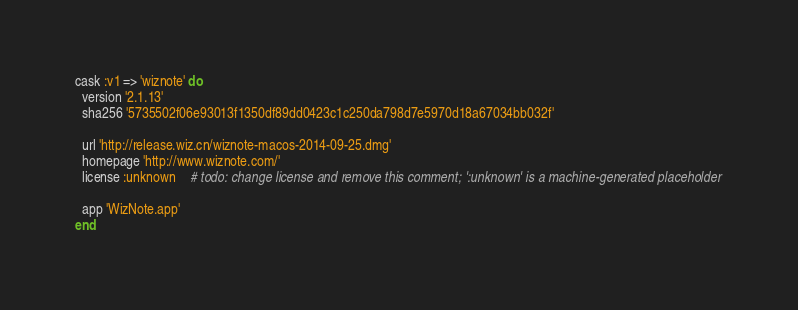Convert code to text. <code><loc_0><loc_0><loc_500><loc_500><_Ruby_>cask :v1 => 'wiznote' do
  version '2.1.13'
  sha256 '5735502f06e93013f1350df89dd0423c1c250da798d7e5970d18a67034bb032f'

  url 'http://release.wiz.cn/wiznote-macos-2014-09-25.dmg'
  homepage 'http://www.wiznote.com/'
  license :unknown    # todo: change license and remove this comment; ':unknown' is a machine-generated placeholder

  app 'WizNote.app'
end
</code> 